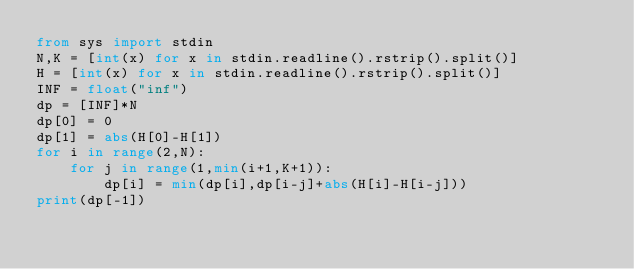<code> <loc_0><loc_0><loc_500><loc_500><_Python_>from sys import stdin
N,K = [int(x) for x in stdin.readline().rstrip().split()]
H = [int(x) for x in stdin.readline().rstrip().split()]
INF = float("inf")
dp = [INF]*N
dp[0] = 0
dp[1] = abs(H[0]-H[1])
for i in range(2,N):
    for j in range(1,min(i+1,K+1)):
        dp[i] = min(dp[i],dp[i-j]+abs(H[i]-H[i-j]))
print(dp[-1])</code> 